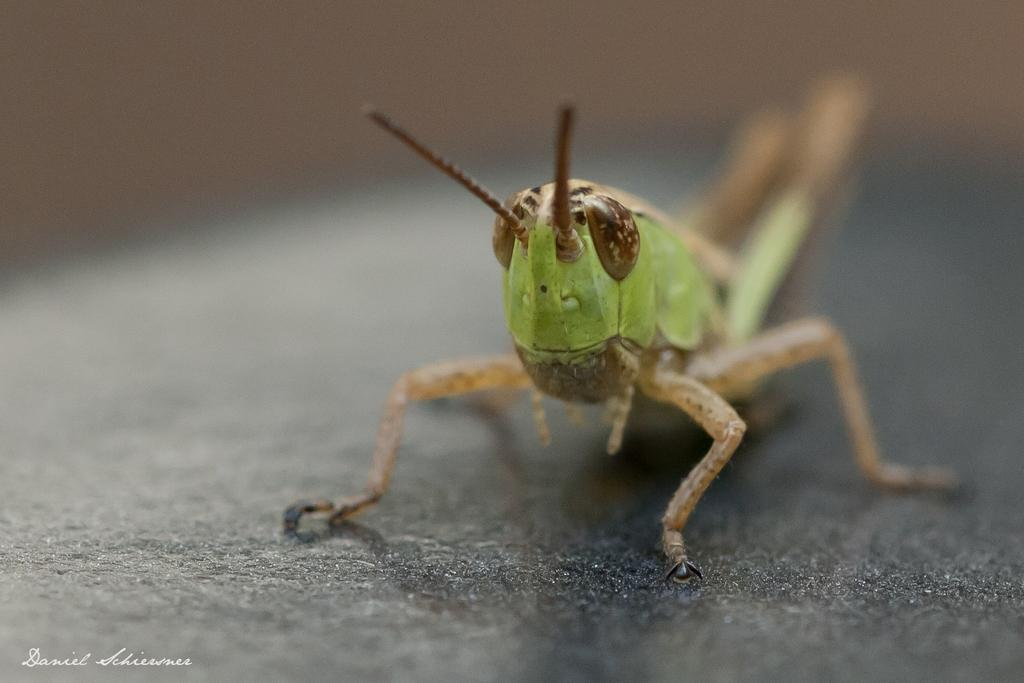What is the main subject of the image? There is a grasshopper in the image. What is the grasshopper standing on? The grasshopper is standing on a black object. Can you describe the background of the image? The background of the image is blurry. Is there any additional information or branding present in the image? Yes, there is a watermark in the bottom left corner of the image. What type of shirt is the grasshopper wearing in the image? There is no shirt present in the image, as the subject is a grasshopper, which does not wear clothing. 